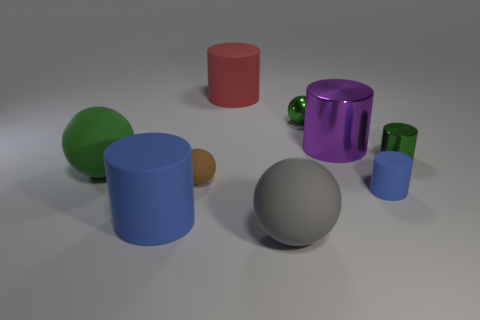Are there the same number of gray matte objects that are to the right of the large metal thing and big purple metal balls?
Your answer should be compact. Yes. There is a sphere that is right of the big ball in front of the blue rubber cylinder to the right of the large red rubber object; what is it made of?
Your answer should be compact. Metal. There is a tiny ball that is right of the red cylinder; what color is it?
Provide a short and direct response. Green. Is there anything else that has the same shape as the large purple object?
Offer a very short reply. Yes. What is the size of the matte object to the left of the large cylinder that is in front of the brown sphere?
Provide a short and direct response. Large. Is the number of tiny rubber objects that are on the right side of the gray matte thing the same as the number of blue things behind the tiny blue matte object?
Your response must be concise. No. Are there any other things that have the same size as the shiny sphere?
Keep it short and to the point. Yes. There is a small cylinder that is made of the same material as the large red object; what color is it?
Offer a very short reply. Blue. Is the large red cylinder made of the same material as the small green thing that is on the right side of the big metal thing?
Offer a very short reply. No. What is the color of the big cylinder that is both on the left side of the large shiny cylinder and to the right of the large blue matte thing?
Ensure brevity in your answer.  Red. 